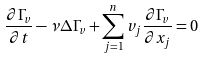Convert formula to latex. <formula><loc_0><loc_0><loc_500><loc_500>\frac { \partial \Gamma _ { v } } { \partial t } - \nu \Delta \Gamma _ { v } + \sum _ { j = 1 } ^ { n } v _ { j } \frac { \partial \Gamma _ { v } } { \partial x _ { j } } = 0</formula> 